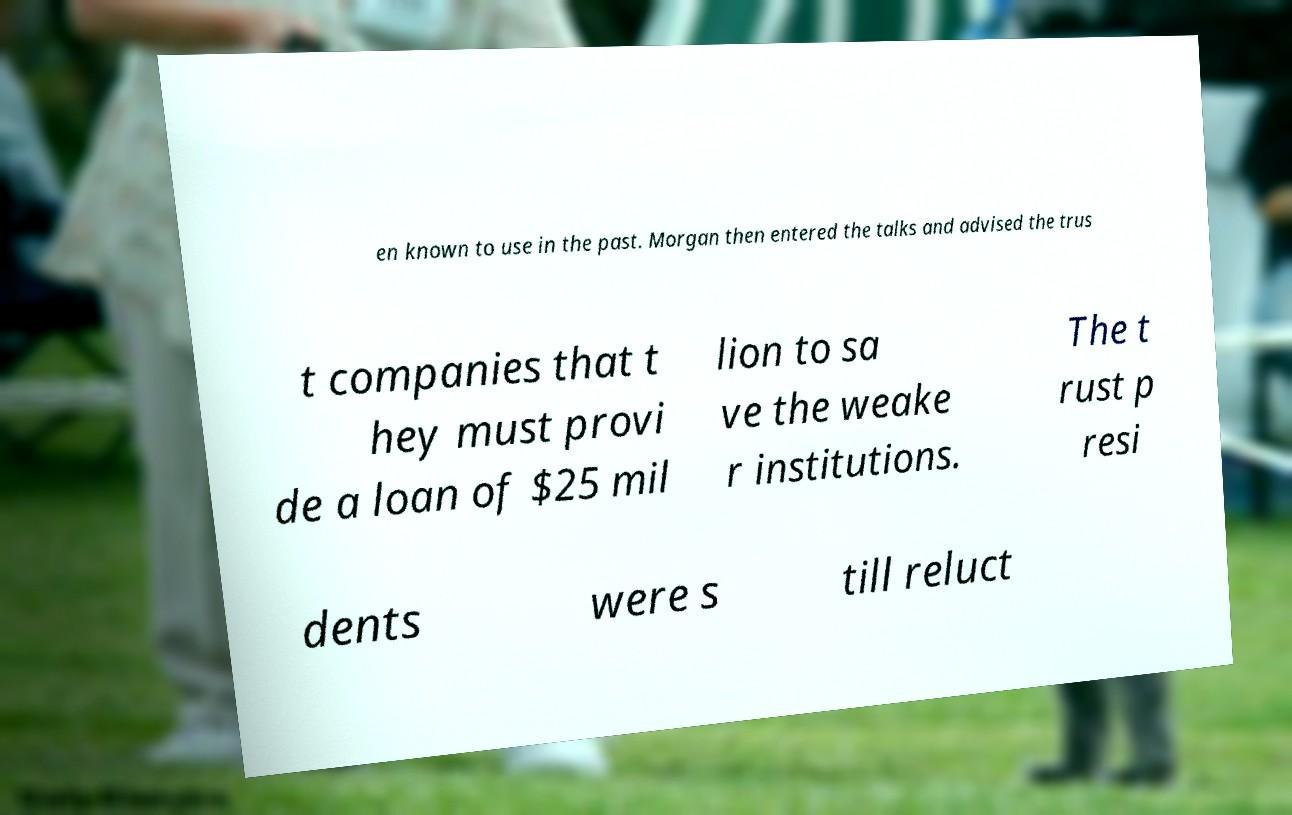There's text embedded in this image that I need extracted. Can you transcribe it verbatim? en known to use in the past. Morgan then entered the talks and advised the trus t companies that t hey must provi de a loan of $25 mil lion to sa ve the weake r institutions. The t rust p resi dents were s till reluct 